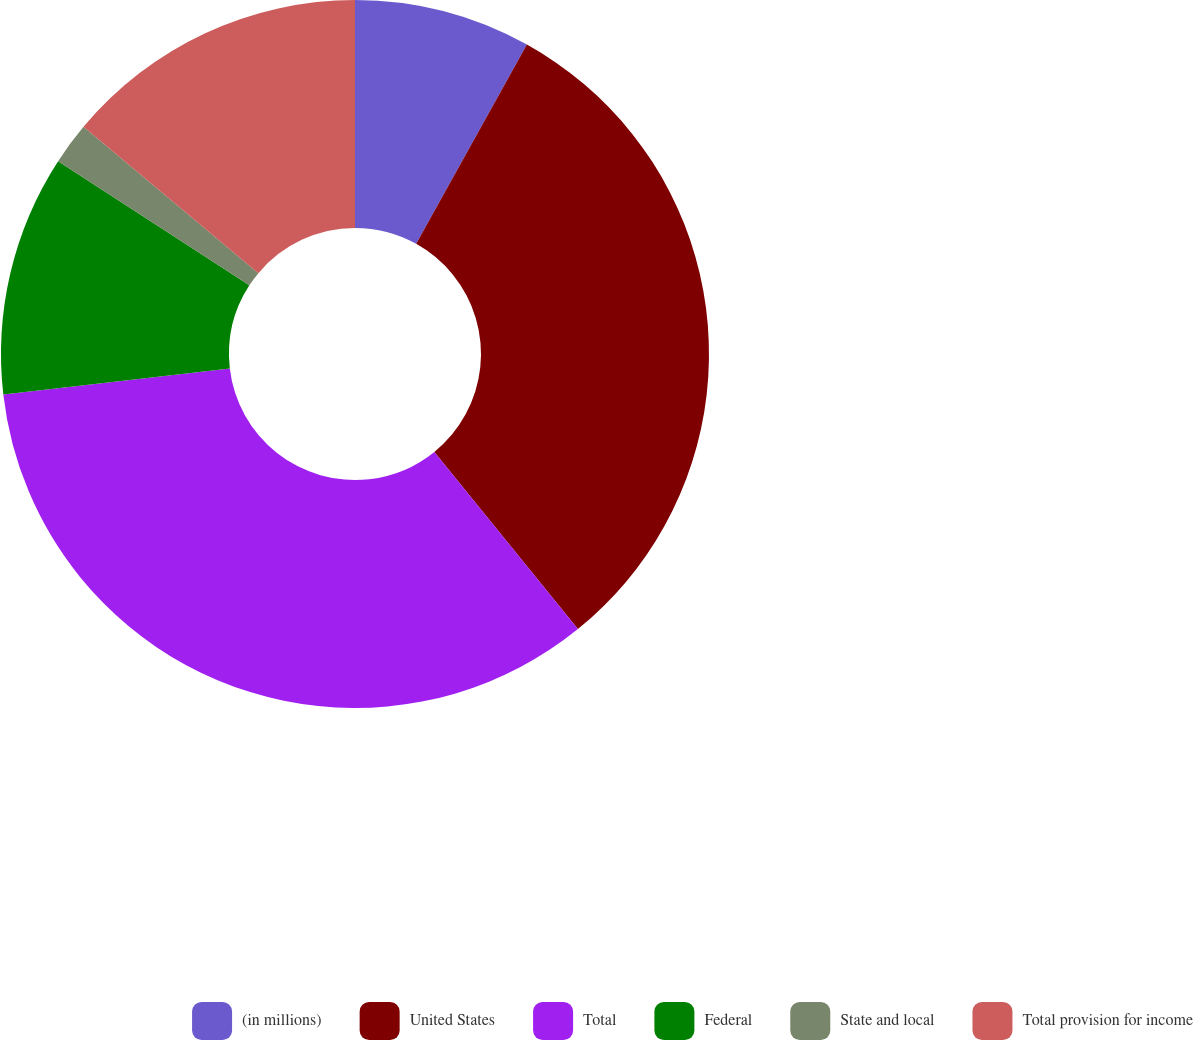Convert chart to OTSL. <chart><loc_0><loc_0><loc_500><loc_500><pie_chart><fcel>(in millions)<fcel>United States<fcel>Total<fcel>Federal<fcel>State and local<fcel>Total provision for income<nl><fcel>8.07%<fcel>31.09%<fcel>34.02%<fcel>10.99%<fcel>1.92%<fcel>13.91%<nl></chart> 